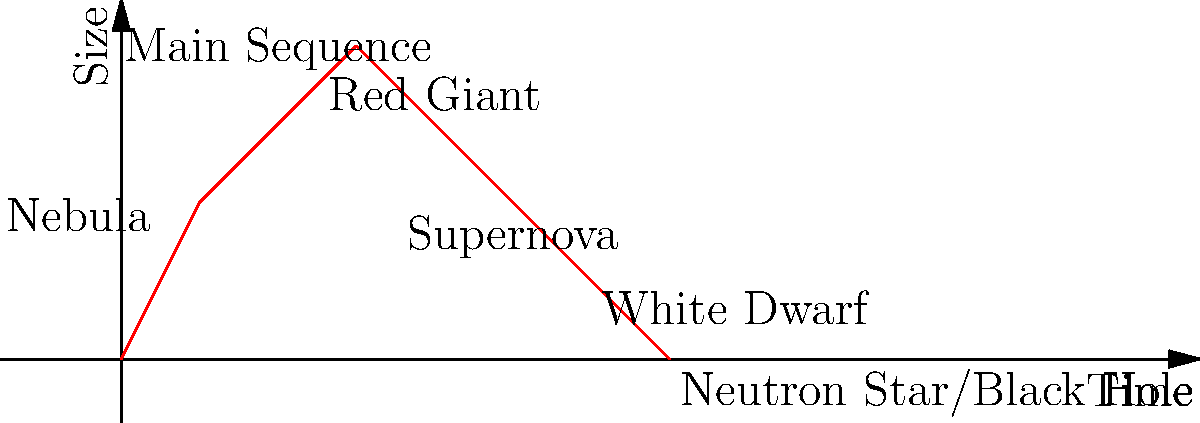In the life cycle of a star, which stage is characterized by a significant increase in size and a cooler surface temperature, often appearing reddish in color? Let's break down the life cycle of a star:

1. Nebula: A cloud of gas and dust where stars are born.
2. Main Sequence: The longest stage where the star fuses hydrogen into helium in its core.
3. Red Giant: As hydrogen in the core is depleted, the star expands and cools, becoming much larger and redder.
4. For lower mass stars:
   a. White Dwarf: The star sheds its outer layers, leaving a small, dense core.
5. For higher mass stars:
   a. Supernova: The star explodes, releasing enormous energy.
   b. Neutron Star or Black Hole: Depending on the initial mass, the remnant becomes either a neutron star or a black hole.

The stage characterized by a significant increase in size and a cooler surface temperature, appearing reddish in color, is the Red Giant stage. This occurs when the star has exhausted the hydrogen in its core and begins fusing hydrogen in a shell around the core, causing the outer layers to expand dramatically.
Answer: Red Giant 